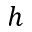Convert formula to latex. <formula><loc_0><loc_0><loc_500><loc_500>h</formula> 